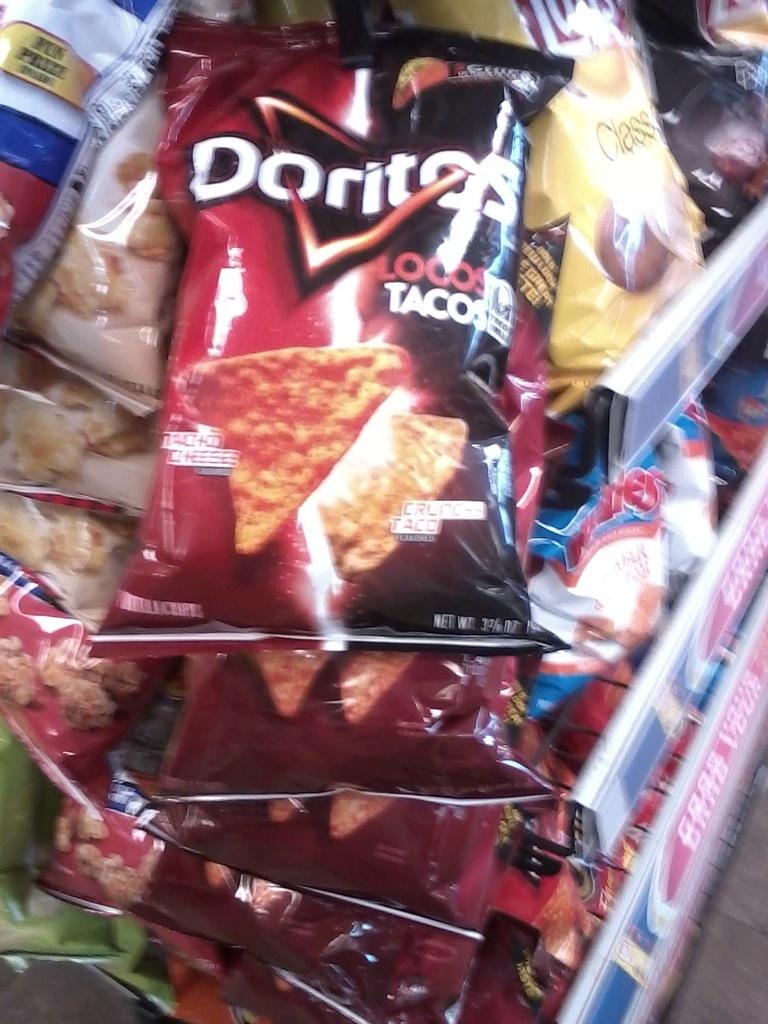What brand of chips?
Your answer should be compact. Doritos. 